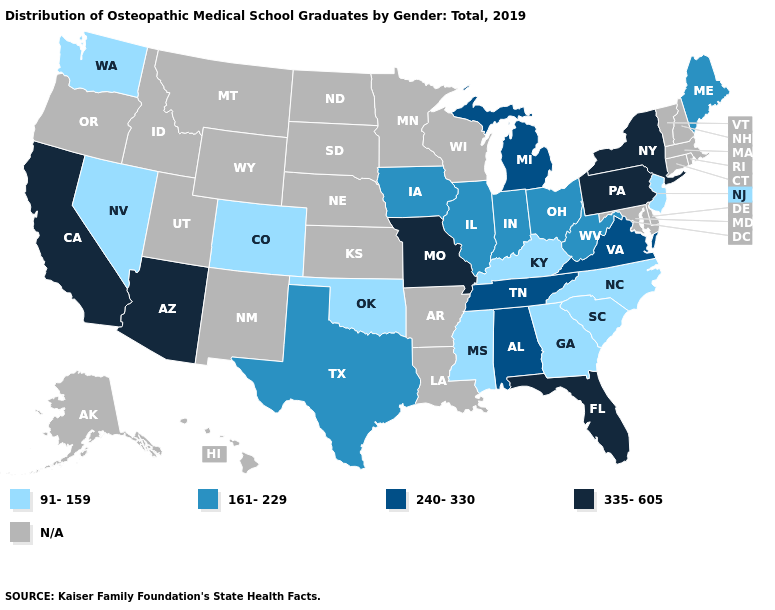What is the lowest value in states that border Arkansas?
Concise answer only. 91-159. Name the states that have a value in the range 91-159?
Answer briefly. Colorado, Georgia, Kentucky, Mississippi, Nevada, New Jersey, North Carolina, Oklahoma, South Carolina, Washington. What is the value of Georgia?
Answer briefly. 91-159. What is the value of Iowa?
Quick response, please. 161-229. What is the highest value in the South ?
Write a very short answer. 335-605. What is the highest value in the USA?
Concise answer only. 335-605. Among the states that border Nebraska , which have the highest value?
Keep it brief. Missouri. What is the value of Montana?
Write a very short answer. N/A. What is the value of New Hampshire?
Give a very brief answer. N/A. Does New Jersey have the highest value in the Northeast?
Keep it brief. No. What is the highest value in the USA?
Answer briefly. 335-605. What is the lowest value in the Northeast?
Keep it brief. 91-159. 